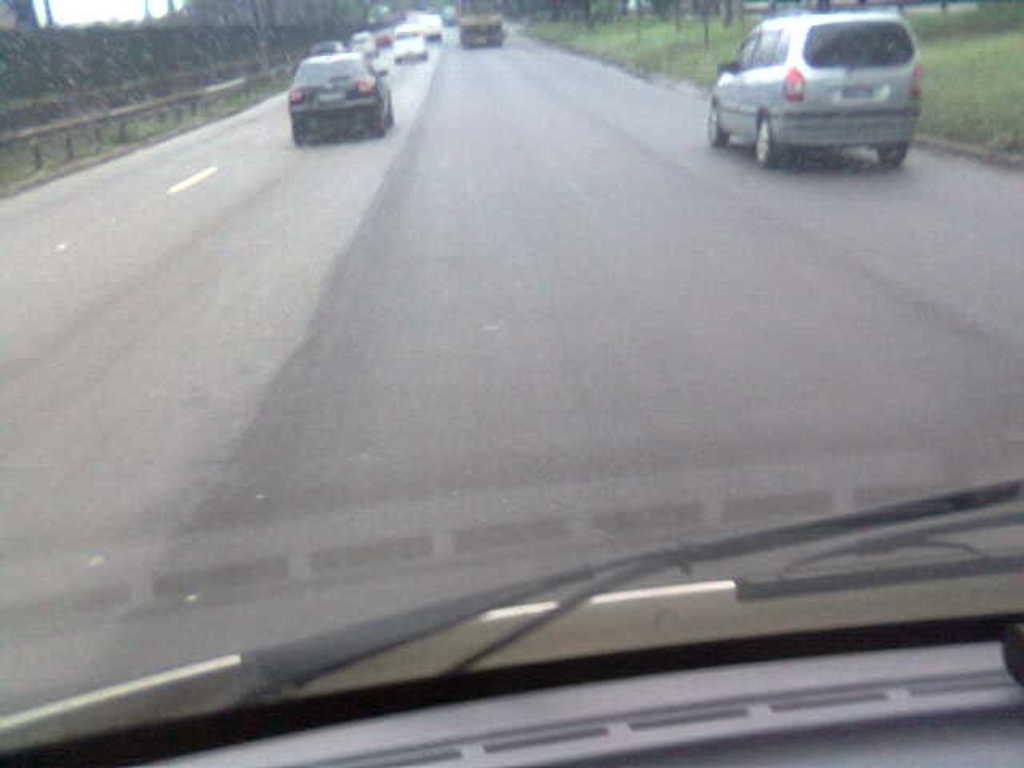In one or two sentences, can you explain what this image depicts? In this picture there are vehicles on the road. In the foreground there is a vehicle and there is an object in the vehicle. Behind the mirror there are buildings and trees and there is a railing. At the top there is sky. At the bottom there is a road and there is grass. 